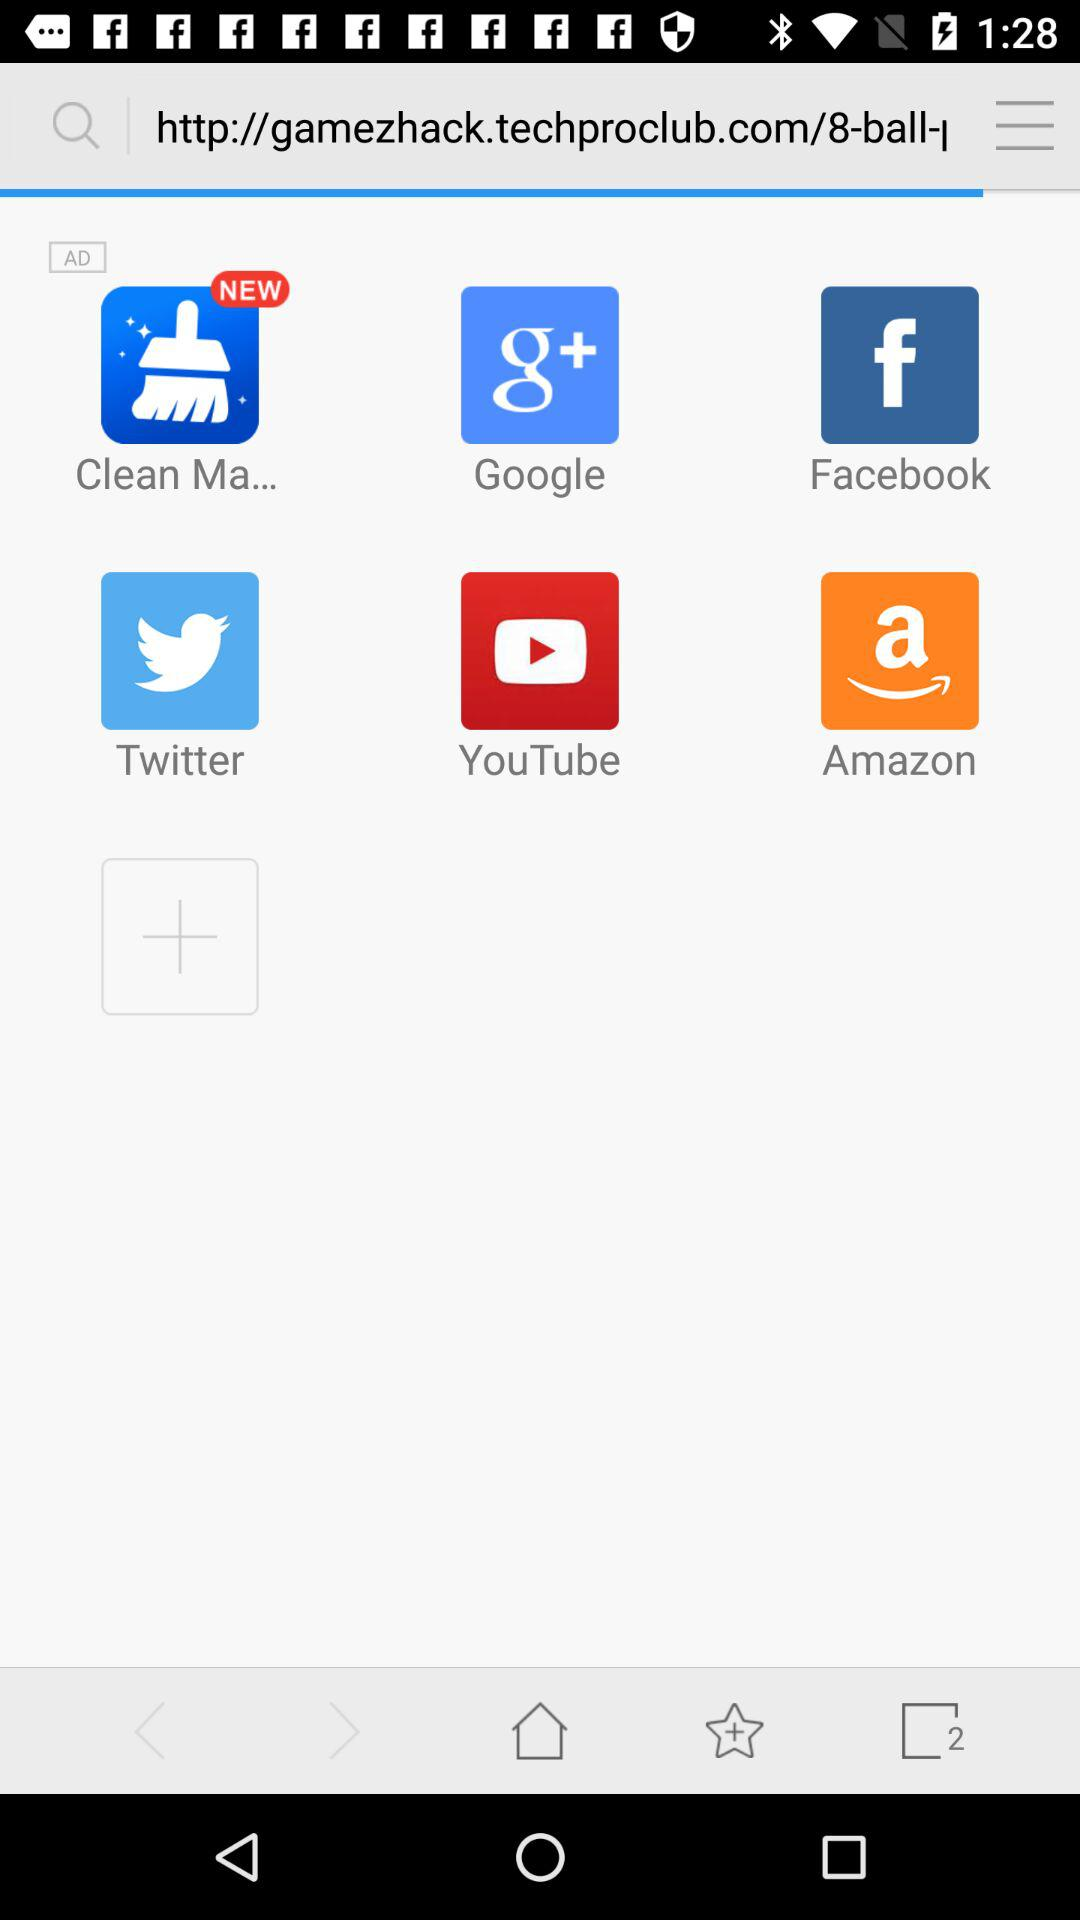Which application is new? The application that is new is "Clean Ma...". 